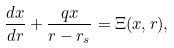<formula> <loc_0><loc_0><loc_500><loc_500>\frac { d x } { d r } + \frac { q x } { r - r _ { s } } = \Xi ( x , r ) ,</formula> 